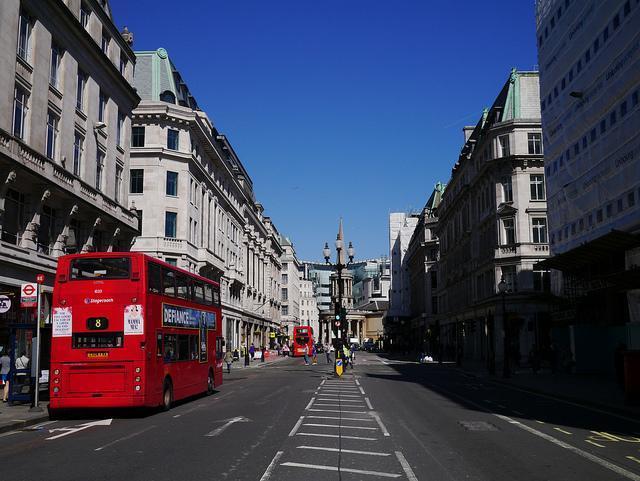How many red buses are there?
Give a very brief answer. 2. How many buses can be seen?
Give a very brief answer. 1. 